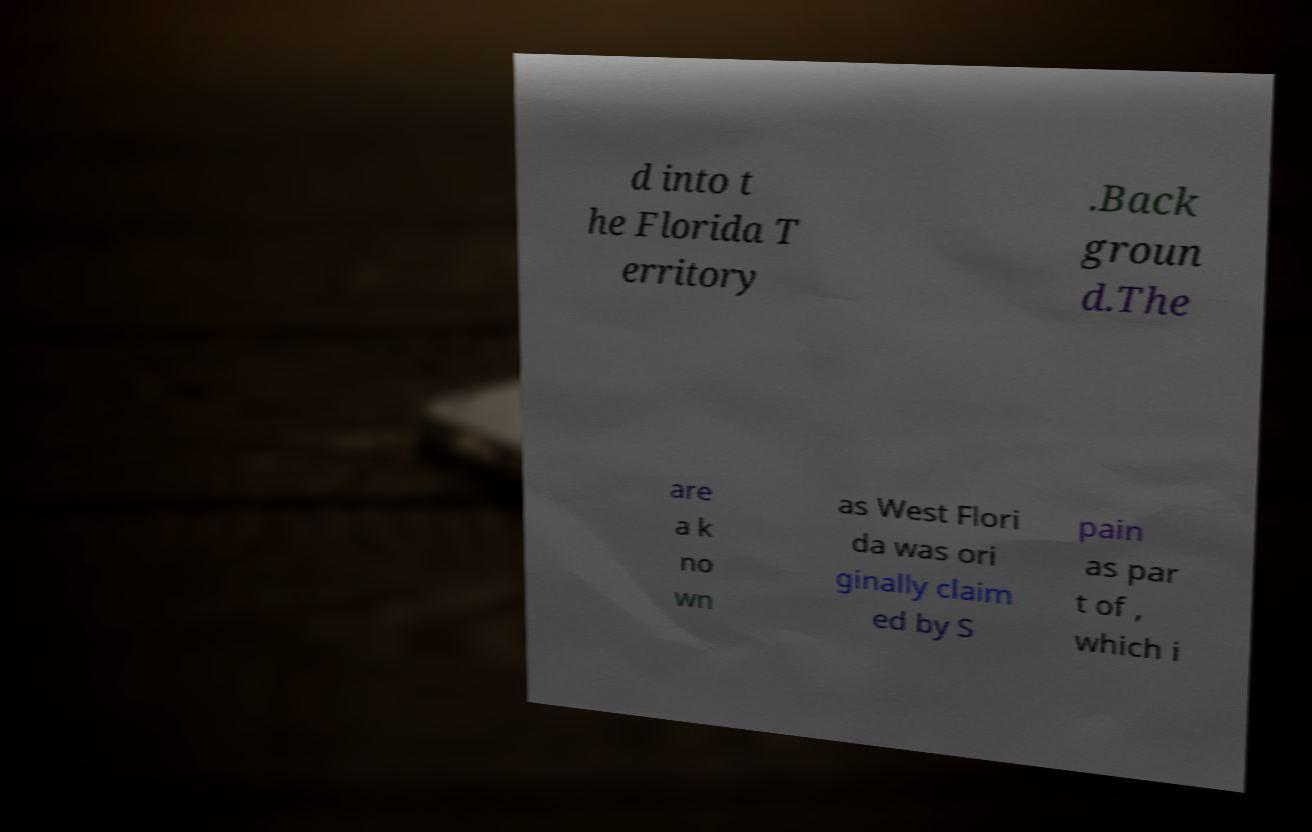For documentation purposes, I need the text within this image transcribed. Could you provide that? d into t he Florida T erritory .Back groun d.The are a k no wn as West Flori da was ori ginally claim ed by S pain as par t of , which i 